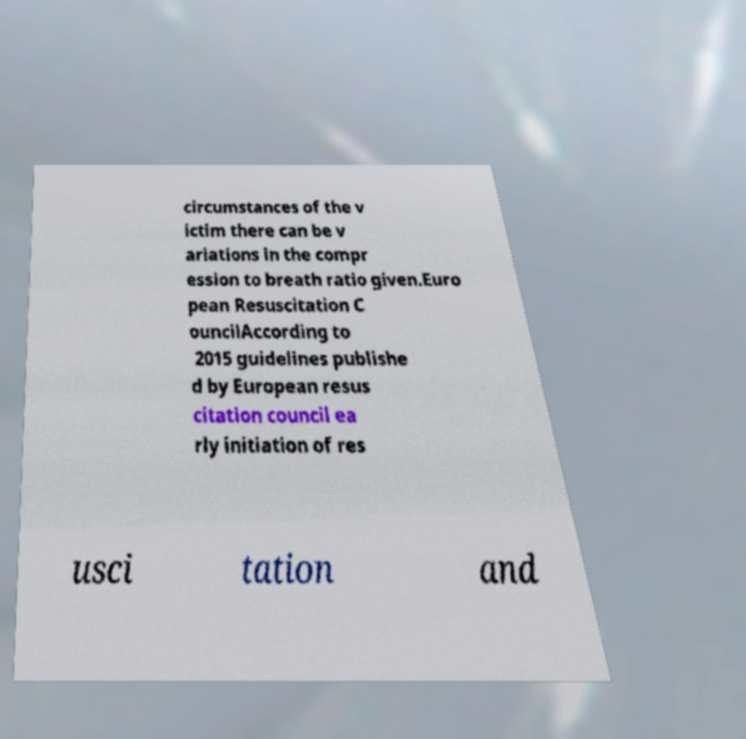Could you assist in decoding the text presented in this image and type it out clearly? circumstances of the v ictim there can be v ariations in the compr ession to breath ratio given.Euro pean Resuscitation C ouncilAccording to 2015 guidelines publishe d by European resus citation council ea rly initiation of res usci tation and 